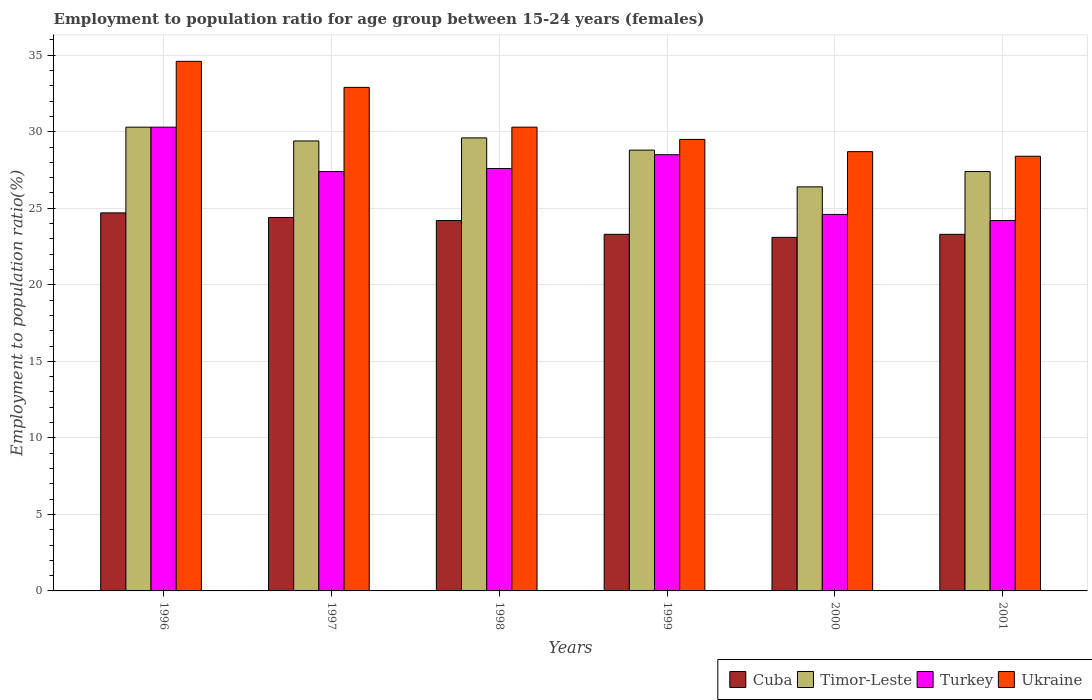How many groups of bars are there?
Provide a short and direct response. 6. Are the number of bars per tick equal to the number of legend labels?
Provide a short and direct response. Yes. Are the number of bars on each tick of the X-axis equal?
Make the answer very short. Yes. How many bars are there on the 3rd tick from the left?
Your answer should be compact. 4. How many bars are there on the 6th tick from the right?
Give a very brief answer. 4. What is the label of the 1st group of bars from the left?
Keep it short and to the point. 1996. In how many cases, is the number of bars for a given year not equal to the number of legend labels?
Make the answer very short. 0. What is the employment to population ratio in Turkey in 2000?
Provide a short and direct response. 24.6. Across all years, what is the maximum employment to population ratio in Cuba?
Provide a succinct answer. 24.7. Across all years, what is the minimum employment to population ratio in Cuba?
Keep it short and to the point. 23.1. In which year was the employment to population ratio in Ukraine minimum?
Offer a very short reply. 2001. What is the total employment to population ratio in Cuba in the graph?
Offer a very short reply. 143. What is the difference between the employment to population ratio in Ukraine in 1998 and that in 2001?
Your answer should be very brief. 1.9. What is the difference between the employment to population ratio in Ukraine in 2001 and the employment to population ratio in Timor-Leste in 1996?
Offer a terse response. -1.9. What is the average employment to population ratio in Turkey per year?
Keep it short and to the point. 27.1. In the year 1998, what is the difference between the employment to population ratio in Timor-Leste and employment to population ratio in Cuba?
Make the answer very short. 5.4. What is the ratio of the employment to population ratio in Timor-Leste in 1998 to that in 1999?
Offer a very short reply. 1.03. What is the difference between the highest and the second highest employment to population ratio in Cuba?
Give a very brief answer. 0.3. What is the difference between the highest and the lowest employment to population ratio in Ukraine?
Provide a succinct answer. 6.2. In how many years, is the employment to population ratio in Timor-Leste greater than the average employment to population ratio in Timor-Leste taken over all years?
Your answer should be very brief. 4. Is the sum of the employment to population ratio in Turkey in 1996 and 1999 greater than the maximum employment to population ratio in Ukraine across all years?
Your response must be concise. Yes. What does the 3rd bar from the left in 2001 represents?
Ensure brevity in your answer.  Turkey. What does the 4th bar from the right in 1999 represents?
Your response must be concise. Cuba. Is it the case that in every year, the sum of the employment to population ratio in Turkey and employment to population ratio in Cuba is greater than the employment to population ratio in Ukraine?
Make the answer very short. Yes. How many bars are there?
Offer a very short reply. 24. Are all the bars in the graph horizontal?
Your answer should be very brief. No. What is the difference between two consecutive major ticks on the Y-axis?
Keep it short and to the point. 5. Are the values on the major ticks of Y-axis written in scientific E-notation?
Make the answer very short. No. Does the graph contain grids?
Keep it short and to the point. Yes. How many legend labels are there?
Give a very brief answer. 4. How are the legend labels stacked?
Ensure brevity in your answer.  Horizontal. What is the title of the graph?
Offer a very short reply. Employment to population ratio for age group between 15-24 years (females). Does "Comoros" appear as one of the legend labels in the graph?
Offer a terse response. No. What is the label or title of the Y-axis?
Provide a succinct answer. Employment to population ratio(%). What is the Employment to population ratio(%) in Cuba in 1996?
Your answer should be very brief. 24.7. What is the Employment to population ratio(%) of Timor-Leste in 1996?
Your answer should be compact. 30.3. What is the Employment to population ratio(%) in Turkey in 1996?
Offer a very short reply. 30.3. What is the Employment to population ratio(%) of Ukraine in 1996?
Offer a terse response. 34.6. What is the Employment to population ratio(%) in Cuba in 1997?
Give a very brief answer. 24.4. What is the Employment to population ratio(%) of Timor-Leste in 1997?
Offer a very short reply. 29.4. What is the Employment to population ratio(%) in Turkey in 1997?
Your answer should be very brief. 27.4. What is the Employment to population ratio(%) in Ukraine in 1997?
Ensure brevity in your answer.  32.9. What is the Employment to population ratio(%) in Cuba in 1998?
Keep it short and to the point. 24.2. What is the Employment to population ratio(%) in Timor-Leste in 1998?
Provide a short and direct response. 29.6. What is the Employment to population ratio(%) in Turkey in 1998?
Keep it short and to the point. 27.6. What is the Employment to population ratio(%) of Ukraine in 1998?
Your response must be concise. 30.3. What is the Employment to population ratio(%) in Cuba in 1999?
Offer a terse response. 23.3. What is the Employment to population ratio(%) of Timor-Leste in 1999?
Provide a short and direct response. 28.8. What is the Employment to population ratio(%) of Ukraine in 1999?
Give a very brief answer. 29.5. What is the Employment to population ratio(%) of Cuba in 2000?
Offer a very short reply. 23.1. What is the Employment to population ratio(%) of Timor-Leste in 2000?
Your response must be concise. 26.4. What is the Employment to population ratio(%) in Turkey in 2000?
Your answer should be very brief. 24.6. What is the Employment to population ratio(%) of Ukraine in 2000?
Offer a terse response. 28.7. What is the Employment to population ratio(%) in Cuba in 2001?
Provide a succinct answer. 23.3. What is the Employment to population ratio(%) of Timor-Leste in 2001?
Give a very brief answer. 27.4. What is the Employment to population ratio(%) of Turkey in 2001?
Your response must be concise. 24.2. What is the Employment to population ratio(%) in Ukraine in 2001?
Keep it short and to the point. 28.4. Across all years, what is the maximum Employment to population ratio(%) in Cuba?
Provide a succinct answer. 24.7. Across all years, what is the maximum Employment to population ratio(%) of Timor-Leste?
Your answer should be very brief. 30.3. Across all years, what is the maximum Employment to population ratio(%) in Turkey?
Your answer should be compact. 30.3. Across all years, what is the maximum Employment to population ratio(%) of Ukraine?
Your answer should be compact. 34.6. Across all years, what is the minimum Employment to population ratio(%) in Cuba?
Your answer should be compact. 23.1. Across all years, what is the minimum Employment to population ratio(%) in Timor-Leste?
Your answer should be very brief. 26.4. Across all years, what is the minimum Employment to population ratio(%) in Turkey?
Offer a very short reply. 24.2. Across all years, what is the minimum Employment to population ratio(%) of Ukraine?
Offer a very short reply. 28.4. What is the total Employment to population ratio(%) in Cuba in the graph?
Your answer should be compact. 143. What is the total Employment to population ratio(%) of Timor-Leste in the graph?
Offer a terse response. 171.9. What is the total Employment to population ratio(%) in Turkey in the graph?
Your response must be concise. 162.6. What is the total Employment to population ratio(%) in Ukraine in the graph?
Your response must be concise. 184.4. What is the difference between the Employment to population ratio(%) in Timor-Leste in 1996 and that in 1998?
Give a very brief answer. 0.7. What is the difference between the Employment to population ratio(%) of Turkey in 1996 and that in 1998?
Keep it short and to the point. 2.7. What is the difference between the Employment to population ratio(%) in Ukraine in 1996 and that in 1998?
Your answer should be compact. 4.3. What is the difference between the Employment to population ratio(%) of Timor-Leste in 1996 and that in 1999?
Make the answer very short. 1.5. What is the difference between the Employment to population ratio(%) in Turkey in 1996 and that in 1999?
Provide a short and direct response. 1.8. What is the difference between the Employment to population ratio(%) of Ukraine in 1996 and that in 1999?
Your answer should be very brief. 5.1. What is the difference between the Employment to population ratio(%) of Turkey in 1996 and that in 2000?
Ensure brevity in your answer.  5.7. What is the difference between the Employment to population ratio(%) of Ukraine in 1996 and that in 2000?
Offer a terse response. 5.9. What is the difference between the Employment to population ratio(%) in Turkey in 1996 and that in 2001?
Keep it short and to the point. 6.1. What is the difference between the Employment to population ratio(%) in Ukraine in 1996 and that in 2001?
Your response must be concise. 6.2. What is the difference between the Employment to population ratio(%) of Timor-Leste in 1997 and that in 1998?
Your answer should be compact. -0.2. What is the difference between the Employment to population ratio(%) in Turkey in 1997 and that in 1998?
Provide a succinct answer. -0.2. What is the difference between the Employment to population ratio(%) of Ukraine in 1997 and that in 1999?
Offer a terse response. 3.4. What is the difference between the Employment to population ratio(%) in Turkey in 1997 and that in 2000?
Your answer should be compact. 2.8. What is the difference between the Employment to population ratio(%) of Cuba in 1997 and that in 2001?
Offer a very short reply. 1.1. What is the difference between the Employment to population ratio(%) of Timor-Leste in 1998 and that in 1999?
Your answer should be compact. 0.8. What is the difference between the Employment to population ratio(%) in Turkey in 1998 and that in 1999?
Keep it short and to the point. -0.9. What is the difference between the Employment to population ratio(%) in Cuba in 1998 and that in 2000?
Provide a short and direct response. 1.1. What is the difference between the Employment to population ratio(%) in Timor-Leste in 1998 and that in 2000?
Ensure brevity in your answer.  3.2. What is the difference between the Employment to population ratio(%) of Ukraine in 1998 and that in 2000?
Your answer should be compact. 1.6. What is the difference between the Employment to population ratio(%) in Cuba in 1998 and that in 2001?
Offer a very short reply. 0.9. What is the difference between the Employment to population ratio(%) in Ukraine in 1998 and that in 2001?
Offer a very short reply. 1.9. What is the difference between the Employment to population ratio(%) of Ukraine in 1999 and that in 2000?
Your answer should be compact. 0.8. What is the difference between the Employment to population ratio(%) in Turkey in 1999 and that in 2001?
Provide a short and direct response. 4.3. What is the difference between the Employment to population ratio(%) in Ukraine in 1999 and that in 2001?
Your answer should be very brief. 1.1. What is the difference between the Employment to population ratio(%) of Ukraine in 2000 and that in 2001?
Your response must be concise. 0.3. What is the difference between the Employment to population ratio(%) of Cuba in 1996 and the Employment to population ratio(%) of Turkey in 1997?
Keep it short and to the point. -2.7. What is the difference between the Employment to population ratio(%) of Cuba in 1996 and the Employment to population ratio(%) of Ukraine in 1997?
Make the answer very short. -8.2. What is the difference between the Employment to population ratio(%) of Cuba in 1996 and the Employment to population ratio(%) of Turkey in 1998?
Provide a short and direct response. -2.9. What is the difference between the Employment to population ratio(%) of Cuba in 1996 and the Employment to population ratio(%) of Ukraine in 1998?
Ensure brevity in your answer.  -5.6. What is the difference between the Employment to population ratio(%) in Timor-Leste in 1996 and the Employment to population ratio(%) in Turkey in 1998?
Keep it short and to the point. 2.7. What is the difference between the Employment to population ratio(%) of Cuba in 1996 and the Employment to population ratio(%) of Timor-Leste in 1999?
Provide a succinct answer. -4.1. What is the difference between the Employment to population ratio(%) of Cuba in 1996 and the Employment to population ratio(%) of Turkey in 1999?
Offer a very short reply. -3.8. What is the difference between the Employment to population ratio(%) of Cuba in 1996 and the Employment to population ratio(%) of Ukraine in 1999?
Make the answer very short. -4.8. What is the difference between the Employment to population ratio(%) of Timor-Leste in 1996 and the Employment to population ratio(%) of Ukraine in 1999?
Offer a very short reply. 0.8. What is the difference between the Employment to population ratio(%) of Turkey in 1996 and the Employment to population ratio(%) of Ukraine in 1999?
Provide a short and direct response. 0.8. What is the difference between the Employment to population ratio(%) in Cuba in 1996 and the Employment to population ratio(%) in Timor-Leste in 2000?
Give a very brief answer. -1.7. What is the difference between the Employment to population ratio(%) in Cuba in 1996 and the Employment to population ratio(%) in Turkey in 2000?
Keep it short and to the point. 0.1. What is the difference between the Employment to population ratio(%) of Turkey in 1996 and the Employment to population ratio(%) of Ukraine in 2000?
Make the answer very short. 1.6. What is the difference between the Employment to population ratio(%) of Timor-Leste in 1996 and the Employment to population ratio(%) of Turkey in 2001?
Provide a short and direct response. 6.1. What is the difference between the Employment to population ratio(%) of Cuba in 1997 and the Employment to population ratio(%) of Timor-Leste in 1998?
Provide a succinct answer. -5.2. What is the difference between the Employment to population ratio(%) in Cuba in 1997 and the Employment to population ratio(%) in Ukraine in 1998?
Your answer should be very brief. -5.9. What is the difference between the Employment to population ratio(%) of Timor-Leste in 1997 and the Employment to population ratio(%) of Ukraine in 1998?
Ensure brevity in your answer.  -0.9. What is the difference between the Employment to population ratio(%) in Cuba in 1997 and the Employment to population ratio(%) in Timor-Leste in 1999?
Offer a terse response. -4.4. What is the difference between the Employment to population ratio(%) of Cuba in 1997 and the Employment to population ratio(%) of Turkey in 1999?
Offer a terse response. -4.1. What is the difference between the Employment to population ratio(%) in Cuba in 1997 and the Employment to population ratio(%) in Ukraine in 1999?
Give a very brief answer. -5.1. What is the difference between the Employment to population ratio(%) in Timor-Leste in 1997 and the Employment to population ratio(%) in Turkey in 1999?
Offer a terse response. 0.9. What is the difference between the Employment to population ratio(%) of Turkey in 1997 and the Employment to population ratio(%) of Ukraine in 1999?
Keep it short and to the point. -2.1. What is the difference between the Employment to population ratio(%) of Cuba in 1997 and the Employment to population ratio(%) of Turkey in 2000?
Keep it short and to the point. -0.2. What is the difference between the Employment to population ratio(%) in Cuba in 1997 and the Employment to population ratio(%) in Ukraine in 2000?
Ensure brevity in your answer.  -4.3. What is the difference between the Employment to population ratio(%) in Timor-Leste in 1997 and the Employment to population ratio(%) in Ukraine in 2001?
Provide a short and direct response. 1. What is the difference between the Employment to population ratio(%) of Turkey in 1997 and the Employment to population ratio(%) of Ukraine in 2001?
Offer a very short reply. -1. What is the difference between the Employment to population ratio(%) in Cuba in 1998 and the Employment to population ratio(%) in Timor-Leste in 1999?
Provide a short and direct response. -4.6. What is the difference between the Employment to population ratio(%) of Cuba in 1998 and the Employment to population ratio(%) of Ukraine in 1999?
Provide a short and direct response. -5.3. What is the difference between the Employment to population ratio(%) in Timor-Leste in 1998 and the Employment to population ratio(%) in Ukraine in 1999?
Ensure brevity in your answer.  0.1. What is the difference between the Employment to population ratio(%) in Turkey in 1998 and the Employment to population ratio(%) in Ukraine in 1999?
Your answer should be very brief. -1.9. What is the difference between the Employment to population ratio(%) of Cuba in 1998 and the Employment to population ratio(%) of Ukraine in 2000?
Keep it short and to the point. -4.5. What is the difference between the Employment to population ratio(%) in Timor-Leste in 1998 and the Employment to population ratio(%) in Ukraine in 2000?
Offer a very short reply. 0.9. What is the difference between the Employment to population ratio(%) in Cuba in 1998 and the Employment to population ratio(%) in Turkey in 2001?
Your answer should be compact. 0. What is the difference between the Employment to population ratio(%) in Timor-Leste in 1998 and the Employment to population ratio(%) in Ukraine in 2001?
Offer a very short reply. 1.2. What is the difference between the Employment to population ratio(%) of Cuba in 1999 and the Employment to population ratio(%) of Timor-Leste in 2000?
Offer a very short reply. -3.1. What is the difference between the Employment to population ratio(%) of Cuba in 1999 and the Employment to population ratio(%) of Turkey in 2000?
Your response must be concise. -1.3. What is the difference between the Employment to population ratio(%) of Timor-Leste in 1999 and the Employment to population ratio(%) of Turkey in 2000?
Give a very brief answer. 4.2. What is the difference between the Employment to population ratio(%) in Turkey in 1999 and the Employment to population ratio(%) in Ukraine in 2000?
Make the answer very short. -0.2. What is the difference between the Employment to population ratio(%) of Turkey in 1999 and the Employment to population ratio(%) of Ukraine in 2001?
Offer a terse response. 0.1. What is the difference between the Employment to population ratio(%) in Cuba in 2000 and the Employment to population ratio(%) in Ukraine in 2001?
Make the answer very short. -5.3. What is the difference between the Employment to population ratio(%) in Timor-Leste in 2000 and the Employment to population ratio(%) in Turkey in 2001?
Your answer should be compact. 2.2. What is the difference between the Employment to population ratio(%) of Turkey in 2000 and the Employment to population ratio(%) of Ukraine in 2001?
Your response must be concise. -3.8. What is the average Employment to population ratio(%) in Cuba per year?
Keep it short and to the point. 23.83. What is the average Employment to population ratio(%) in Timor-Leste per year?
Keep it short and to the point. 28.65. What is the average Employment to population ratio(%) in Turkey per year?
Your response must be concise. 27.1. What is the average Employment to population ratio(%) of Ukraine per year?
Provide a succinct answer. 30.73. In the year 1996, what is the difference between the Employment to population ratio(%) of Cuba and Employment to population ratio(%) of Turkey?
Offer a very short reply. -5.6. In the year 1996, what is the difference between the Employment to population ratio(%) of Cuba and Employment to population ratio(%) of Ukraine?
Give a very brief answer. -9.9. In the year 1996, what is the difference between the Employment to population ratio(%) of Timor-Leste and Employment to population ratio(%) of Turkey?
Keep it short and to the point. 0. In the year 1996, what is the difference between the Employment to population ratio(%) in Timor-Leste and Employment to population ratio(%) in Ukraine?
Offer a very short reply. -4.3. In the year 1996, what is the difference between the Employment to population ratio(%) in Turkey and Employment to population ratio(%) in Ukraine?
Provide a short and direct response. -4.3. In the year 1997, what is the difference between the Employment to population ratio(%) of Cuba and Employment to population ratio(%) of Turkey?
Make the answer very short. -3. In the year 1997, what is the difference between the Employment to population ratio(%) of Cuba and Employment to population ratio(%) of Ukraine?
Provide a short and direct response. -8.5. In the year 1997, what is the difference between the Employment to population ratio(%) in Timor-Leste and Employment to population ratio(%) in Ukraine?
Offer a terse response. -3.5. In the year 1998, what is the difference between the Employment to population ratio(%) of Cuba and Employment to population ratio(%) of Timor-Leste?
Your answer should be compact. -5.4. In the year 1998, what is the difference between the Employment to population ratio(%) of Cuba and Employment to population ratio(%) of Turkey?
Your answer should be very brief. -3.4. In the year 1998, what is the difference between the Employment to population ratio(%) of Cuba and Employment to population ratio(%) of Ukraine?
Your answer should be compact. -6.1. In the year 1998, what is the difference between the Employment to population ratio(%) of Timor-Leste and Employment to population ratio(%) of Ukraine?
Offer a terse response. -0.7. In the year 1998, what is the difference between the Employment to population ratio(%) of Turkey and Employment to population ratio(%) of Ukraine?
Keep it short and to the point. -2.7. In the year 1999, what is the difference between the Employment to population ratio(%) of Cuba and Employment to population ratio(%) of Timor-Leste?
Your response must be concise. -5.5. In the year 1999, what is the difference between the Employment to population ratio(%) in Timor-Leste and Employment to population ratio(%) in Turkey?
Provide a succinct answer. 0.3. In the year 1999, what is the difference between the Employment to population ratio(%) in Timor-Leste and Employment to population ratio(%) in Ukraine?
Your answer should be very brief. -0.7. In the year 2000, what is the difference between the Employment to population ratio(%) in Cuba and Employment to population ratio(%) in Turkey?
Offer a very short reply. -1.5. In the year 2000, what is the difference between the Employment to population ratio(%) of Cuba and Employment to population ratio(%) of Ukraine?
Provide a succinct answer. -5.6. In the year 2000, what is the difference between the Employment to population ratio(%) of Timor-Leste and Employment to population ratio(%) of Ukraine?
Provide a succinct answer. -2.3. In the year 2000, what is the difference between the Employment to population ratio(%) of Turkey and Employment to population ratio(%) of Ukraine?
Offer a terse response. -4.1. In the year 2001, what is the difference between the Employment to population ratio(%) in Cuba and Employment to population ratio(%) in Turkey?
Provide a succinct answer. -0.9. In the year 2001, what is the difference between the Employment to population ratio(%) of Timor-Leste and Employment to population ratio(%) of Ukraine?
Make the answer very short. -1. What is the ratio of the Employment to population ratio(%) in Cuba in 1996 to that in 1997?
Make the answer very short. 1.01. What is the ratio of the Employment to population ratio(%) of Timor-Leste in 1996 to that in 1997?
Offer a terse response. 1.03. What is the ratio of the Employment to population ratio(%) of Turkey in 1996 to that in 1997?
Provide a short and direct response. 1.11. What is the ratio of the Employment to population ratio(%) in Ukraine in 1996 to that in 1997?
Give a very brief answer. 1.05. What is the ratio of the Employment to population ratio(%) in Cuba in 1996 to that in 1998?
Your response must be concise. 1.02. What is the ratio of the Employment to population ratio(%) of Timor-Leste in 1996 to that in 1998?
Provide a short and direct response. 1.02. What is the ratio of the Employment to population ratio(%) in Turkey in 1996 to that in 1998?
Make the answer very short. 1.1. What is the ratio of the Employment to population ratio(%) of Ukraine in 1996 to that in 1998?
Offer a terse response. 1.14. What is the ratio of the Employment to population ratio(%) in Cuba in 1996 to that in 1999?
Make the answer very short. 1.06. What is the ratio of the Employment to population ratio(%) in Timor-Leste in 1996 to that in 1999?
Your answer should be very brief. 1.05. What is the ratio of the Employment to population ratio(%) in Turkey in 1996 to that in 1999?
Your answer should be very brief. 1.06. What is the ratio of the Employment to population ratio(%) in Ukraine in 1996 to that in 1999?
Give a very brief answer. 1.17. What is the ratio of the Employment to population ratio(%) in Cuba in 1996 to that in 2000?
Ensure brevity in your answer.  1.07. What is the ratio of the Employment to population ratio(%) in Timor-Leste in 1996 to that in 2000?
Give a very brief answer. 1.15. What is the ratio of the Employment to population ratio(%) in Turkey in 1996 to that in 2000?
Your answer should be very brief. 1.23. What is the ratio of the Employment to population ratio(%) in Ukraine in 1996 to that in 2000?
Offer a very short reply. 1.21. What is the ratio of the Employment to population ratio(%) in Cuba in 1996 to that in 2001?
Make the answer very short. 1.06. What is the ratio of the Employment to population ratio(%) of Timor-Leste in 1996 to that in 2001?
Provide a short and direct response. 1.11. What is the ratio of the Employment to population ratio(%) of Turkey in 1996 to that in 2001?
Make the answer very short. 1.25. What is the ratio of the Employment to population ratio(%) of Ukraine in 1996 to that in 2001?
Offer a terse response. 1.22. What is the ratio of the Employment to population ratio(%) of Cuba in 1997 to that in 1998?
Your response must be concise. 1.01. What is the ratio of the Employment to population ratio(%) in Ukraine in 1997 to that in 1998?
Offer a very short reply. 1.09. What is the ratio of the Employment to population ratio(%) of Cuba in 1997 to that in 1999?
Make the answer very short. 1.05. What is the ratio of the Employment to population ratio(%) of Timor-Leste in 1997 to that in 1999?
Provide a short and direct response. 1.02. What is the ratio of the Employment to population ratio(%) in Turkey in 1997 to that in 1999?
Provide a succinct answer. 0.96. What is the ratio of the Employment to population ratio(%) in Ukraine in 1997 to that in 1999?
Offer a very short reply. 1.12. What is the ratio of the Employment to population ratio(%) in Cuba in 1997 to that in 2000?
Make the answer very short. 1.06. What is the ratio of the Employment to population ratio(%) in Timor-Leste in 1997 to that in 2000?
Your answer should be compact. 1.11. What is the ratio of the Employment to population ratio(%) in Turkey in 1997 to that in 2000?
Provide a succinct answer. 1.11. What is the ratio of the Employment to population ratio(%) of Ukraine in 1997 to that in 2000?
Keep it short and to the point. 1.15. What is the ratio of the Employment to population ratio(%) in Cuba in 1997 to that in 2001?
Offer a very short reply. 1.05. What is the ratio of the Employment to population ratio(%) of Timor-Leste in 1997 to that in 2001?
Make the answer very short. 1.07. What is the ratio of the Employment to population ratio(%) in Turkey in 1997 to that in 2001?
Provide a succinct answer. 1.13. What is the ratio of the Employment to population ratio(%) in Ukraine in 1997 to that in 2001?
Make the answer very short. 1.16. What is the ratio of the Employment to population ratio(%) in Cuba in 1998 to that in 1999?
Offer a very short reply. 1.04. What is the ratio of the Employment to population ratio(%) of Timor-Leste in 1998 to that in 1999?
Your answer should be compact. 1.03. What is the ratio of the Employment to population ratio(%) in Turkey in 1998 to that in 1999?
Your answer should be compact. 0.97. What is the ratio of the Employment to population ratio(%) of Ukraine in 1998 to that in 1999?
Keep it short and to the point. 1.03. What is the ratio of the Employment to population ratio(%) in Cuba in 1998 to that in 2000?
Ensure brevity in your answer.  1.05. What is the ratio of the Employment to population ratio(%) of Timor-Leste in 1998 to that in 2000?
Your response must be concise. 1.12. What is the ratio of the Employment to population ratio(%) in Turkey in 1998 to that in 2000?
Make the answer very short. 1.12. What is the ratio of the Employment to population ratio(%) of Ukraine in 1998 to that in 2000?
Your response must be concise. 1.06. What is the ratio of the Employment to population ratio(%) in Cuba in 1998 to that in 2001?
Your answer should be compact. 1.04. What is the ratio of the Employment to population ratio(%) of Timor-Leste in 1998 to that in 2001?
Offer a terse response. 1.08. What is the ratio of the Employment to population ratio(%) of Turkey in 1998 to that in 2001?
Make the answer very short. 1.14. What is the ratio of the Employment to population ratio(%) in Ukraine in 1998 to that in 2001?
Ensure brevity in your answer.  1.07. What is the ratio of the Employment to population ratio(%) in Cuba in 1999 to that in 2000?
Your answer should be very brief. 1.01. What is the ratio of the Employment to population ratio(%) of Turkey in 1999 to that in 2000?
Your response must be concise. 1.16. What is the ratio of the Employment to population ratio(%) of Ukraine in 1999 to that in 2000?
Provide a short and direct response. 1.03. What is the ratio of the Employment to population ratio(%) of Timor-Leste in 1999 to that in 2001?
Make the answer very short. 1.05. What is the ratio of the Employment to population ratio(%) of Turkey in 1999 to that in 2001?
Your answer should be very brief. 1.18. What is the ratio of the Employment to population ratio(%) in Ukraine in 1999 to that in 2001?
Your response must be concise. 1.04. What is the ratio of the Employment to population ratio(%) of Cuba in 2000 to that in 2001?
Make the answer very short. 0.99. What is the ratio of the Employment to population ratio(%) of Timor-Leste in 2000 to that in 2001?
Offer a terse response. 0.96. What is the ratio of the Employment to population ratio(%) in Turkey in 2000 to that in 2001?
Give a very brief answer. 1.02. What is the ratio of the Employment to population ratio(%) in Ukraine in 2000 to that in 2001?
Make the answer very short. 1.01. What is the difference between the highest and the second highest Employment to population ratio(%) in Cuba?
Give a very brief answer. 0.3. What is the difference between the highest and the second highest Employment to population ratio(%) of Turkey?
Offer a terse response. 1.8. What is the difference between the highest and the lowest Employment to population ratio(%) in Cuba?
Ensure brevity in your answer.  1.6. What is the difference between the highest and the lowest Employment to population ratio(%) of Turkey?
Provide a short and direct response. 6.1. What is the difference between the highest and the lowest Employment to population ratio(%) in Ukraine?
Ensure brevity in your answer.  6.2. 